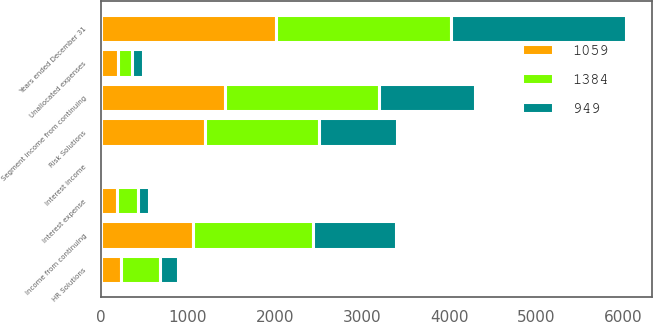Convert chart to OTSL. <chart><loc_0><loc_0><loc_500><loc_500><stacked_bar_chart><ecel><fcel>Years ended December 31<fcel>Risk Solutions<fcel>HR Solutions<fcel>Segment income from continuing<fcel>Unallocated expenses<fcel>Interest income<fcel>Interest expense<fcel>Income from continuing<nl><fcel>1384<fcel>2011<fcel>1314<fcel>448<fcel>1762<fcel>156<fcel>18<fcel>245<fcel>1384<nl><fcel>1059<fcel>2010<fcel>1194<fcel>234<fcel>1428<fcel>202<fcel>15<fcel>182<fcel>1059<nl><fcel>949<fcel>2009<fcel>900<fcel>203<fcel>1103<fcel>131<fcel>16<fcel>122<fcel>949<nl></chart> 